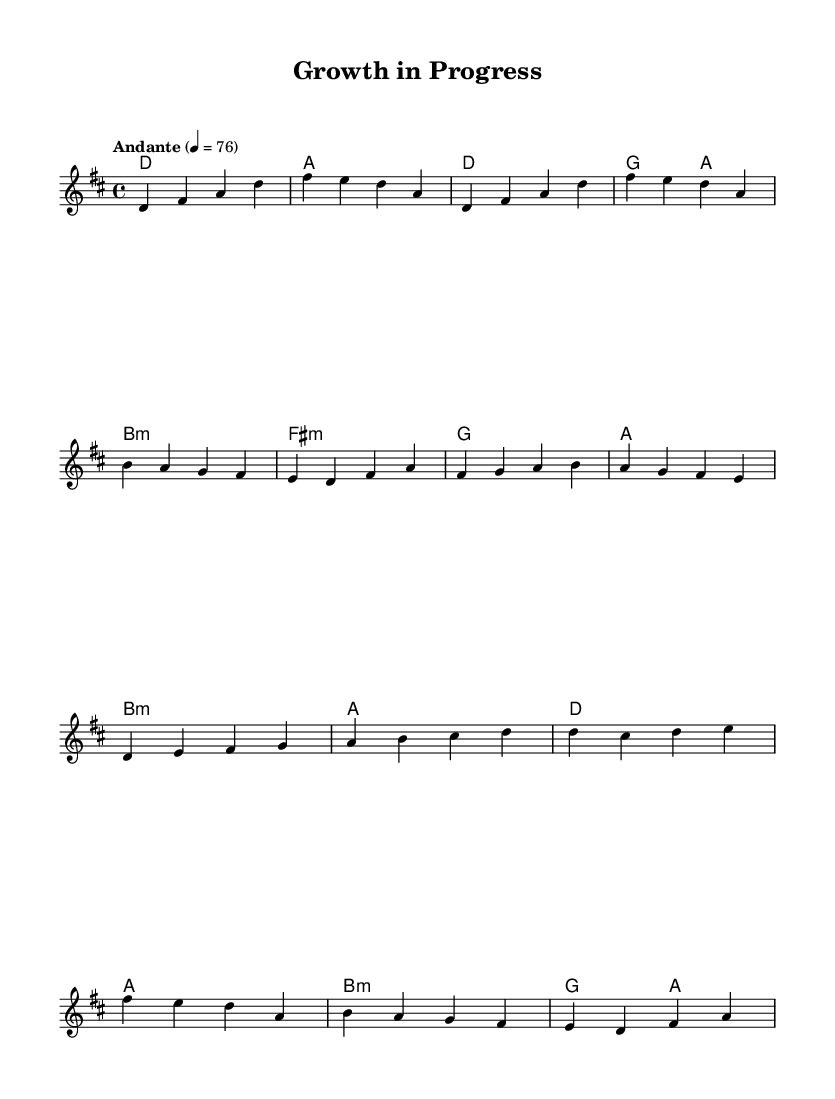What is the key signature of this music? The key signature is D major, which has two sharps (F# and C#). This can be determined by looking at the initial part of the sheet music where the key signature is indicated.
Answer: D major What is the time signature of this music? The time signature is 4/4, as indicated at the beginning of the score. This means there are four beats in each measure.
Answer: 4/4 What is the tempo marking of this piece? The tempo marking is Andante, which suggests a moderately slow tempo. This is specified in the tempo direction at the start of the music.
Answer: Andante How many measures are in the chorus? The chorus consists of 4 measures. By counting the segments in the chorus section of the music, we find there are four distinct measures.
Answer: 4 What chord is sustained throughout the intro? The chord sustained throughout the intro is D major. This is noted in the harmonies section at the beginning.
Answer: D major What is the primary theme of the lyrics implied by the song title? The implied theme of the lyrics is personal growth. The title "Growth in Progress" suggests a focus on introspection and development.
Answer: Personal growth Which section follows the pre-chorus in this song structure? The section that follows the pre-chorus is the chorus. This can be determined by looking at the structure of the song as indicated in the melodies and harmonies.
Answer: Chorus 